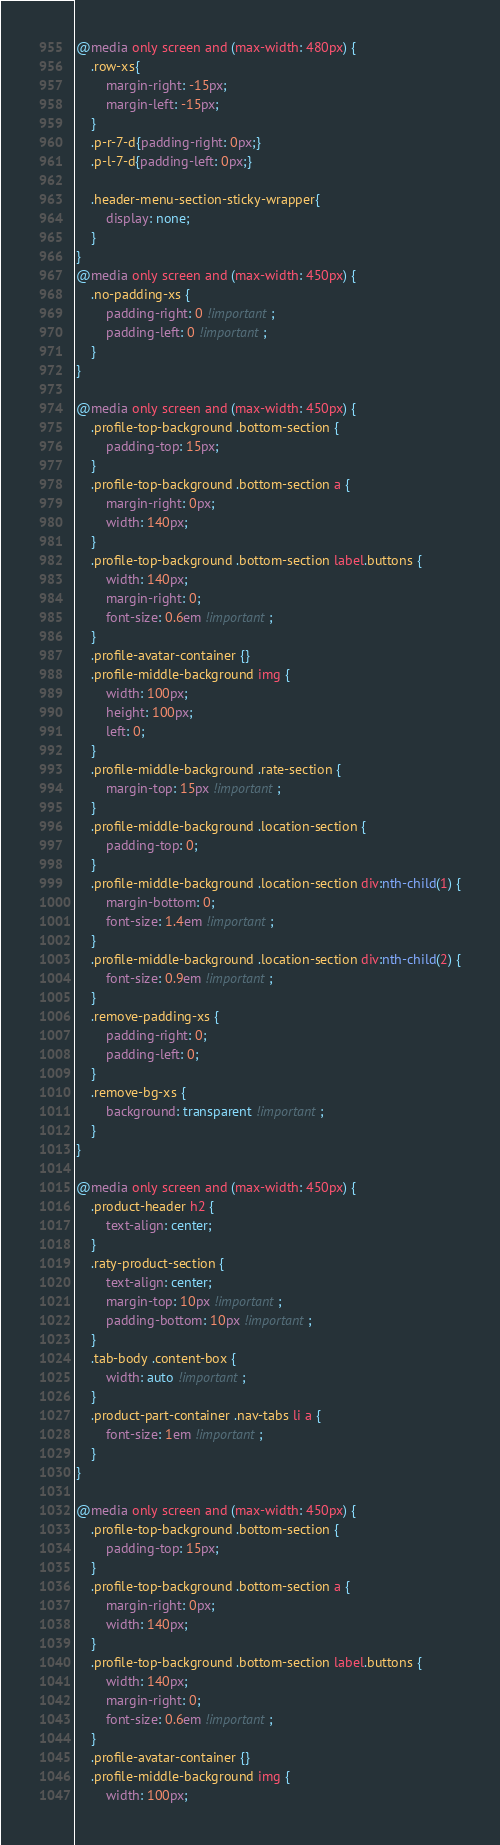<code> <loc_0><loc_0><loc_500><loc_500><_CSS_>@media only screen and (max-width: 480px) {
    .row-xs{
        margin-right: -15px;
        margin-left: -15px;
    }
    .p-r-7-d{padding-right: 0px;}
    .p-l-7-d{padding-left: 0px;}

    .header-menu-section-sticky-wrapper{
        display: none;
    }
}
@media only screen and (max-width: 450px) {
	.no-padding-xs {
		padding-right: 0 !important;
		padding-left: 0 !important;
	}
}

@media only screen and (max-width: 450px) {
	.profile-top-background .bottom-section {
		padding-top: 15px;
	}
	.profile-top-background .bottom-section a {
		margin-right: 0px;
		width: 140px;
	}
	.profile-top-background .bottom-section label.buttons {
		width: 140px;
		margin-right: 0;
		font-size: 0.6em !important;
	}
	.profile-avatar-container {}
	.profile-middle-background img {
		width: 100px;
		height: 100px;
		left: 0;
	}
	.profile-middle-background .rate-section {
		margin-top: 15px !important;
	}
	.profile-middle-background .location-section {
		padding-top: 0;
	}
	.profile-middle-background .location-section div:nth-child(1) {
		margin-bottom: 0;
		font-size: 1.4em !important;
	}
	.profile-middle-background .location-section div:nth-child(2) {
		font-size: 0.9em !important;
	}
	.remove-padding-xs {
		padding-right: 0;
		padding-left: 0;
	}
	.remove-bg-xs {
		background: transparent !important;
	}
}

@media only screen and (max-width: 450px) {
	.product-header h2 {
		text-align: center;
	}
	.raty-product-section {
		text-align: center;
		margin-top: 10px !important;
		padding-bottom: 10px !important;
	}
	.tab-body .content-box {
		width: auto !important;
	}
	.product-part-container .nav-tabs li a {
		font-size: 1em !important;
	}
}

@media only screen and (max-width: 450px) {
	.profile-top-background .bottom-section {
		padding-top: 15px;
	}
	.profile-top-background .bottom-section a {
		margin-right: 0px;
		width: 140px;
	}
	.profile-top-background .bottom-section label.buttons {
		width: 140px;
		margin-right: 0;
		font-size: 0.6em !important;
	}
	.profile-avatar-container {}
	.profile-middle-background img {
		width: 100px;</code> 